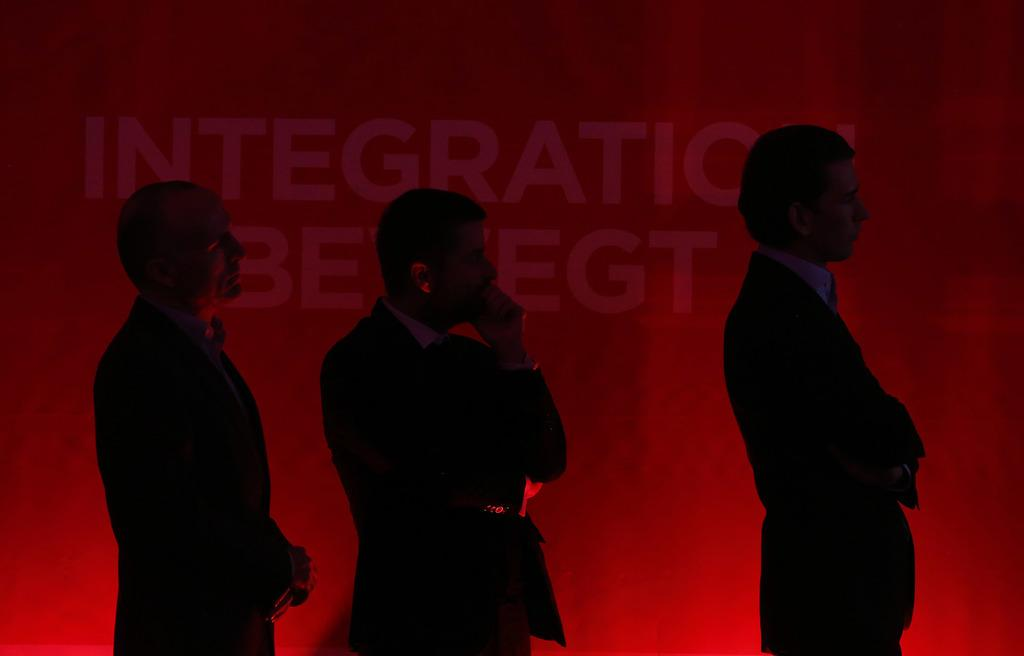How many people are present in the image? There are three people in the image. What are the people wearing? The people are wearing blazers and shirts. What color is the background in the image? The background in the image is red. Is there any text or writing on the background? Yes, there is something written on the background. What type of transport is being used by the people in the image? There is no transport visible in the image; it only shows three people wearing blazers and shirts against a red background with writing on it. What kind of treatment is being administered to the people in the image? There is no indication of any treatment being administered to the people in the image. 